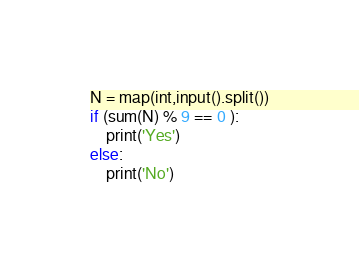<code> <loc_0><loc_0><loc_500><loc_500><_Python_>N = map(int,input().split())
if (sum(N) % 9 == 0 ):
    print('Yes')
else:
    print('No')</code> 